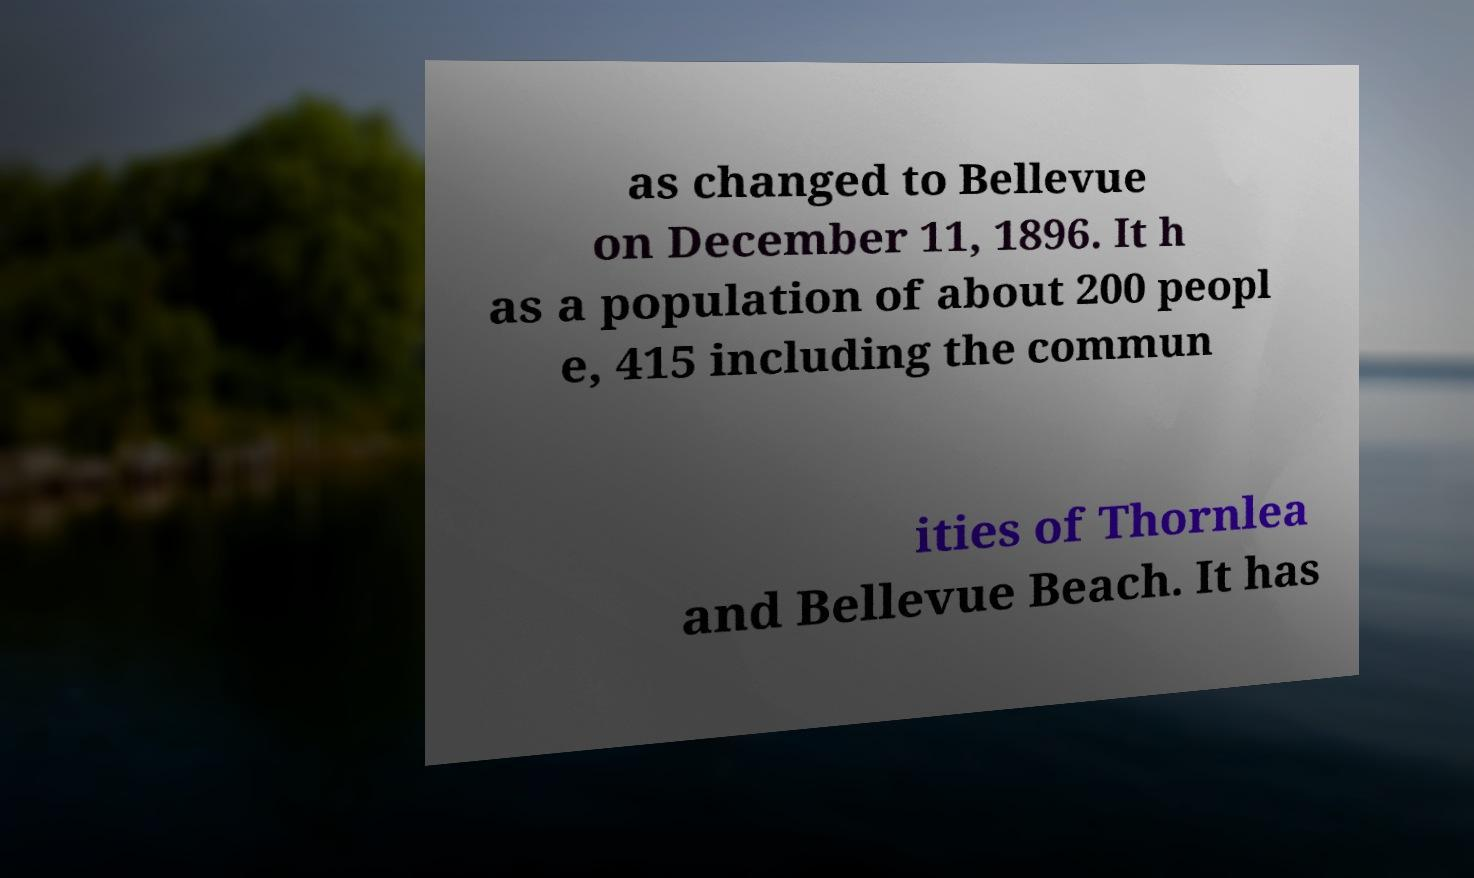I need the written content from this picture converted into text. Can you do that? as changed to Bellevue on December 11, 1896. It h as a population of about 200 peopl e, 415 including the commun ities of Thornlea and Bellevue Beach. It has 